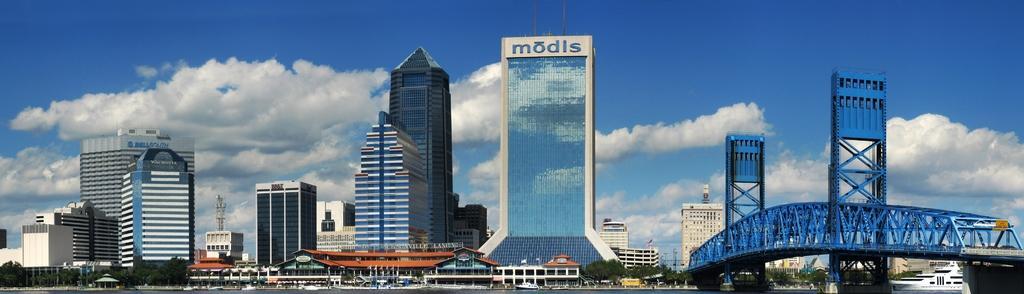In one or two sentences, can you explain what this image depicts? These are the buildings and skyscrapers. This looks like a bridge, which is blue in color. At the bottom of the image, I can see the boats on the water. These are the trees. I can see the clouds in the sky. On the right side of the image, that looks like a cruise ship. 